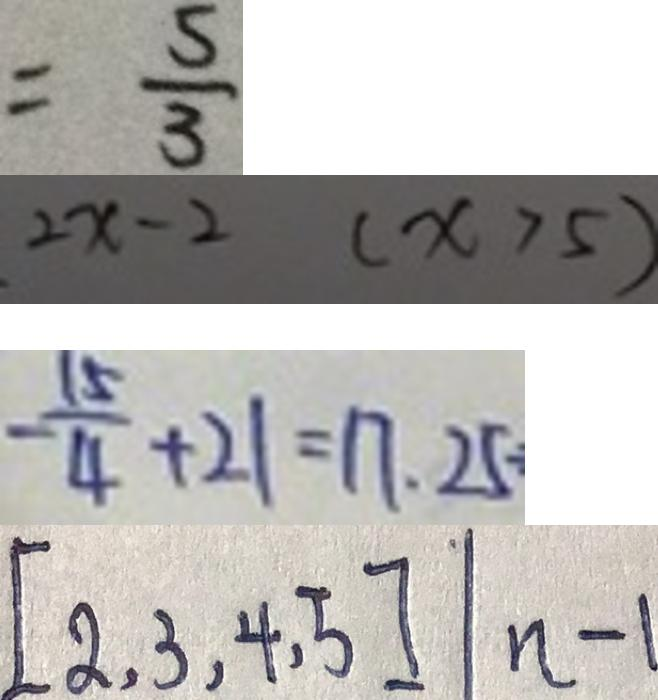<formula> <loc_0><loc_0><loc_500><loc_500>= \frac { 5 } { 3 } 
 2 x - 2 ( x > 5 ) 
 - \frac { 1 5 } { 4 } + 2 1 = 1 7 . 2 5 
 [ 2 , 3 , 4 , 5 ] \vert n - 1</formula> 